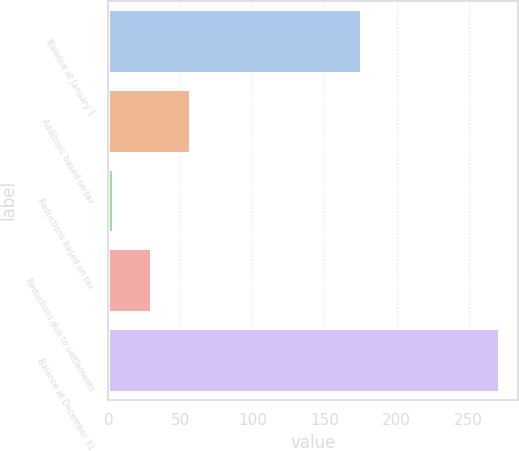Convert chart. <chart><loc_0><loc_0><loc_500><loc_500><bar_chart><fcel>Balance at January 1<fcel>Additions based on tax<fcel>Reductions based on tax<fcel>Reductions due to settlements<fcel>Balance at December 31<nl><fcel>175<fcel>56.6<fcel>3<fcel>29.8<fcel>271<nl></chart> 